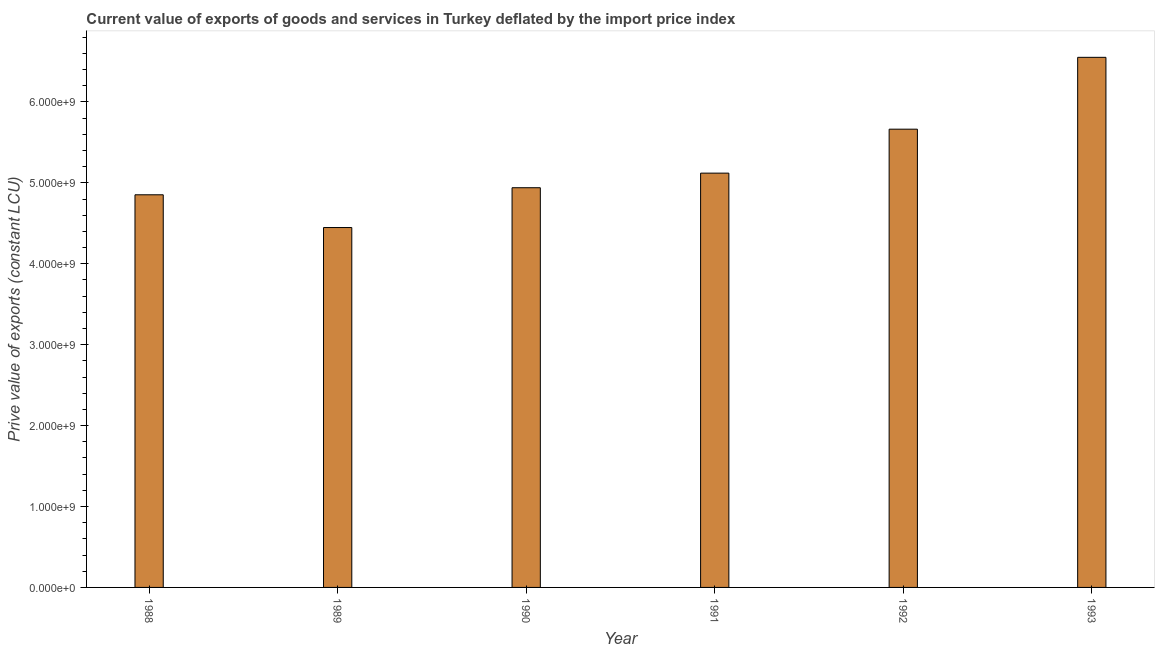Does the graph contain any zero values?
Your answer should be very brief. No. Does the graph contain grids?
Provide a succinct answer. No. What is the title of the graph?
Ensure brevity in your answer.  Current value of exports of goods and services in Turkey deflated by the import price index. What is the label or title of the X-axis?
Give a very brief answer. Year. What is the label or title of the Y-axis?
Your answer should be compact. Prive value of exports (constant LCU). What is the price value of exports in 1988?
Offer a very short reply. 4.85e+09. Across all years, what is the maximum price value of exports?
Make the answer very short. 6.55e+09. Across all years, what is the minimum price value of exports?
Provide a succinct answer. 4.45e+09. In which year was the price value of exports minimum?
Your answer should be very brief. 1989. What is the sum of the price value of exports?
Offer a terse response. 3.16e+1. What is the difference between the price value of exports in 1990 and 1993?
Make the answer very short. -1.61e+09. What is the average price value of exports per year?
Your response must be concise. 5.26e+09. What is the median price value of exports?
Offer a very short reply. 5.03e+09. In how many years, is the price value of exports greater than 4200000000 LCU?
Your response must be concise. 6. Do a majority of the years between 1992 and 1989 (inclusive) have price value of exports greater than 2200000000 LCU?
Provide a short and direct response. Yes. What is the ratio of the price value of exports in 1989 to that in 1991?
Your answer should be compact. 0.87. Is the price value of exports in 1988 less than that in 1990?
Provide a short and direct response. Yes. What is the difference between the highest and the second highest price value of exports?
Make the answer very short. 8.88e+08. What is the difference between the highest and the lowest price value of exports?
Offer a terse response. 2.10e+09. How many years are there in the graph?
Provide a succinct answer. 6. What is the difference between two consecutive major ticks on the Y-axis?
Your answer should be very brief. 1.00e+09. What is the Prive value of exports (constant LCU) of 1988?
Ensure brevity in your answer.  4.85e+09. What is the Prive value of exports (constant LCU) in 1989?
Offer a terse response. 4.45e+09. What is the Prive value of exports (constant LCU) in 1990?
Give a very brief answer. 4.94e+09. What is the Prive value of exports (constant LCU) in 1991?
Make the answer very short. 5.12e+09. What is the Prive value of exports (constant LCU) of 1992?
Ensure brevity in your answer.  5.66e+09. What is the Prive value of exports (constant LCU) of 1993?
Offer a terse response. 6.55e+09. What is the difference between the Prive value of exports (constant LCU) in 1988 and 1989?
Make the answer very short. 4.05e+08. What is the difference between the Prive value of exports (constant LCU) in 1988 and 1990?
Your response must be concise. -8.72e+07. What is the difference between the Prive value of exports (constant LCU) in 1988 and 1991?
Keep it short and to the point. -2.67e+08. What is the difference between the Prive value of exports (constant LCU) in 1988 and 1992?
Provide a short and direct response. -8.11e+08. What is the difference between the Prive value of exports (constant LCU) in 1988 and 1993?
Ensure brevity in your answer.  -1.70e+09. What is the difference between the Prive value of exports (constant LCU) in 1989 and 1990?
Provide a succinct answer. -4.92e+08. What is the difference between the Prive value of exports (constant LCU) in 1989 and 1991?
Your response must be concise. -6.72e+08. What is the difference between the Prive value of exports (constant LCU) in 1989 and 1992?
Your response must be concise. -1.22e+09. What is the difference between the Prive value of exports (constant LCU) in 1989 and 1993?
Offer a terse response. -2.10e+09. What is the difference between the Prive value of exports (constant LCU) in 1990 and 1991?
Your answer should be very brief. -1.80e+08. What is the difference between the Prive value of exports (constant LCU) in 1990 and 1992?
Keep it short and to the point. -7.23e+08. What is the difference between the Prive value of exports (constant LCU) in 1990 and 1993?
Provide a short and direct response. -1.61e+09. What is the difference between the Prive value of exports (constant LCU) in 1991 and 1992?
Make the answer very short. -5.43e+08. What is the difference between the Prive value of exports (constant LCU) in 1991 and 1993?
Your answer should be compact. -1.43e+09. What is the difference between the Prive value of exports (constant LCU) in 1992 and 1993?
Give a very brief answer. -8.88e+08. What is the ratio of the Prive value of exports (constant LCU) in 1988 to that in 1989?
Make the answer very short. 1.09. What is the ratio of the Prive value of exports (constant LCU) in 1988 to that in 1991?
Make the answer very short. 0.95. What is the ratio of the Prive value of exports (constant LCU) in 1988 to that in 1992?
Your answer should be very brief. 0.86. What is the ratio of the Prive value of exports (constant LCU) in 1988 to that in 1993?
Your response must be concise. 0.74. What is the ratio of the Prive value of exports (constant LCU) in 1989 to that in 1991?
Your answer should be compact. 0.87. What is the ratio of the Prive value of exports (constant LCU) in 1989 to that in 1992?
Your answer should be compact. 0.79. What is the ratio of the Prive value of exports (constant LCU) in 1989 to that in 1993?
Give a very brief answer. 0.68. What is the ratio of the Prive value of exports (constant LCU) in 1990 to that in 1992?
Offer a terse response. 0.87. What is the ratio of the Prive value of exports (constant LCU) in 1990 to that in 1993?
Keep it short and to the point. 0.75. What is the ratio of the Prive value of exports (constant LCU) in 1991 to that in 1992?
Your answer should be compact. 0.9. What is the ratio of the Prive value of exports (constant LCU) in 1991 to that in 1993?
Offer a terse response. 0.78. What is the ratio of the Prive value of exports (constant LCU) in 1992 to that in 1993?
Provide a short and direct response. 0.86. 